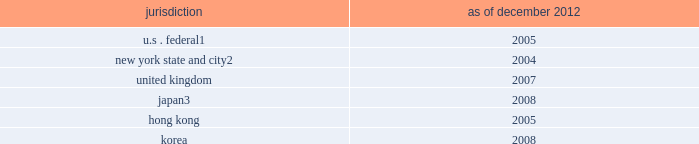Notes to consolidated financial statements regulatory tax examinations the firm is subject to examination by the u.s .
Internal revenue service ( irs ) and other taxing authorities in jurisdictions where the firm has significant business operations , such as the united kingdom , japan , hong kong , korea and various states , such as new york .
The tax years under examination vary by jurisdiction .
The firm believes that during 2013 , certain audits have a reasonable possibility of being completed .
The firm does not expect completion of these audits to have a material impact on the firm 2019s financial condition but it may be material to operating results for a particular period , depending , in part , on the operating results for that period .
The table below presents the earliest tax years that remain subject to examination by major jurisdiction .
Jurisdiction december 2012 u.s .
Federal 1 2005 new york state and city 2 2004 .
Irs examination of fiscal 2008 through calendar 2010 began during 2011 .
Irs examination of fiscal 2005 , 2006 and 2007 began during 2008 .
Irs examination of fiscal 2003 and 2004 has been completed , but the liabilities for those years are not yet final .
The firm anticipates that the audits of fiscal 2005 through calendar 2010 should be completed during 2013 , and the audits of 2011 through 2012 should begin in 2013 .
New york state and city examination of fiscal 2004 , 2005 and 2006 began in 2008 .
Japan national tax agency examination of fiscal 2005 through 2009 began in 2010 .
The examinations have been completed , but the liabilities for 2008 and 2009 are not yet final .
All years subsequent to the above remain open to examination by the taxing authorities .
The firm believes that the liability for unrecognized tax benefits it has established is adequate in relation to the potential for additional assessments .
In january 2013 , the firm was accepted into the compliance assurance process program by the irs .
This program will allow the firm to work with the irs to identify and resolve potential u.s .
Federal tax issues before the filing of tax returns .
The 2013 tax year will be the first year examined under the program .
Note 25 .
Business segments the firm reports its activities in the following four business segments : investment banking , institutional client services , investing & lending and investment management .
Basis of presentation in reporting segments , certain of the firm 2019s business lines have been aggregated where they have similar economic characteristics and are similar in each of the following areas : ( i ) the nature of the services they provide , ( ii ) their methods of distribution , ( iii ) the types of clients they serve and ( iv ) the regulatory environments in which they operate .
The cost drivers of the firm taken as a whole 2014 compensation , headcount and levels of business activity 2014 are broadly similar in each of the firm 2019s business segments .
Compensation and benefits expenses in the firm 2019s segments reflect , among other factors , the overall performance of the firm as well as the performance of individual businesses .
Consequently , pre-tax margins in one segment of the firm 2019s business may be significantly affected by the performance of the firm 2019s other business segments .
The firm allocates assets ( including allocations of excess liquidity and cash , secured client financing and other assets ) , revenues and expenses among the four reportable business segments .
Due to the integrated nature of these segments , estimates and judgments are made in allocating certain assets , revenues and expenses .
Transactions between segments are based on specific criteria or approximate third-party rates .
Total operating expenses include corporate items that have not been allocated to individual business segments .
The allocation process is based on the manner in which management currently views the performance of the segments .
Goldman sachs 2012 annual report 195 .
As of december 2012 , in years , was the hong kong exam opened earlier than the korea exam? 
Computations: (2005 > 2008)
Answer: no. 